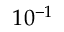<formula> <loc_0><loc_0><loc_500><loc_500>1 0 ^ { - 1 }</formula> 